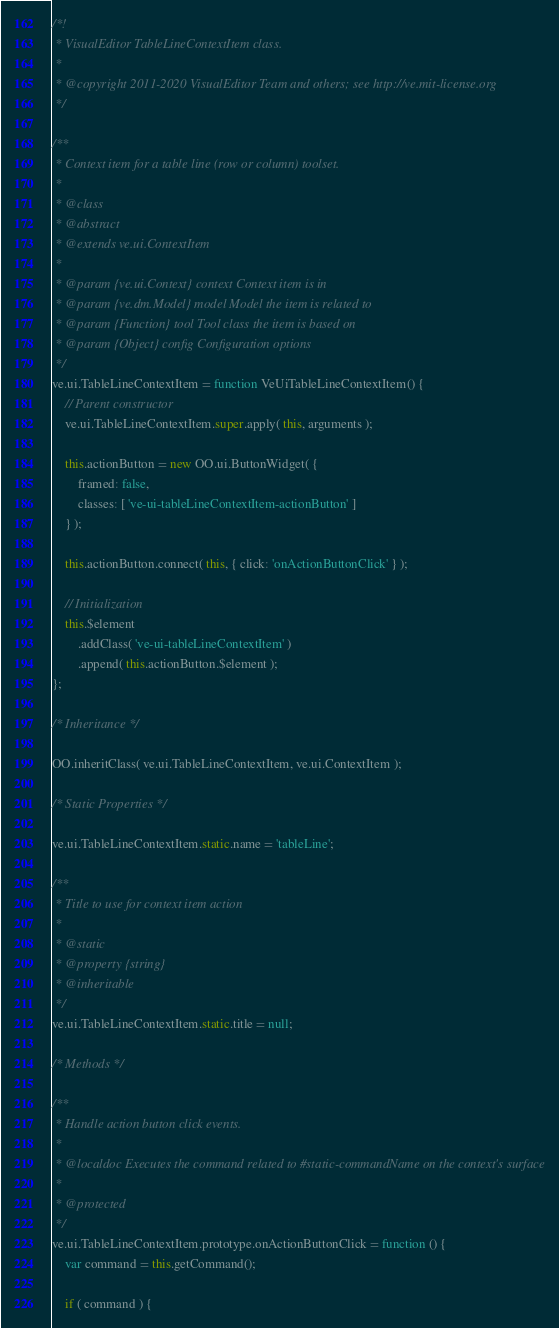Convert code to text. <code><loc_0><loc_0><loc_500><loc_500><_JavaScript_>/*!
 * VisualEditor TableLineContextItem class.
 *
 * @copyright 2011-2020 VisualEditor Team and others; see http://ve.mit-license.org
 */

/**
 * Context item for a table line (row or column) toolset.
 *
 * @class
 * @abstract
 * @extends ve.ui.ContextItem
 *
 * @param {ve.ui.Context} context Context item is in
 * @param {ve.dm.Model} model Model the item is related to
 * @param {Function} tool Tool class the item is based on
 * @param {Object} config Configuration options
 */
ve.ui.TableLineContextItem = function VeUiTableLineContextItem() {
	// Parent constructor
	ve.ui.TableLineContextItem.super.apply( this, arguments );

	this.actionButton = new OO.ui.ButtonWidget( {
		framed: false,
		classes: [ 've-ui-tableLineContextItem-actionButton' ]
	} );

	this.actionButton.connect( this, { click: 'onActionButtonClick' } );

	// Initialization
	this.$element
		.addClass( 've-ui-tableLineContextItem' )
		.append( this.actionButton.$element );
};

/* Inheritance */

OO.inheritClass( ve.ui.TableLineContextItem, ve.ui.ContextItem );

/* Static Properties */

ve.ui.TableLineContextItem.static.name = 'tableLine';

/**
 * Title to use for context item action
 *
 * @static
 * @property {string}
 * @inheritable
 */
ve.ui.TableLineContextItem.static.title = null;

/* Methods */

/**
 * Handle action button click events.
 *
 * @localdoc Executes the command related to #static-commandName on the context's surface
 *
 * @protected
 */
ve.ui.TableLineContextItem.prototype.onActionButtonClick = function () {
	var command = this.getCommand();

	if ( command ) {</code> 